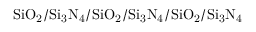<formula> <loc_0><loc_0><loc_500><loc_500>S i O _ { 2 } / S i _ { 3 } N _ { 4 } / S i O _ { 2 } / S i _ { 3 } N _ { 4 } / S i O _ { 2 } / S i _ { 3 } N _ { 4 }</formula> 